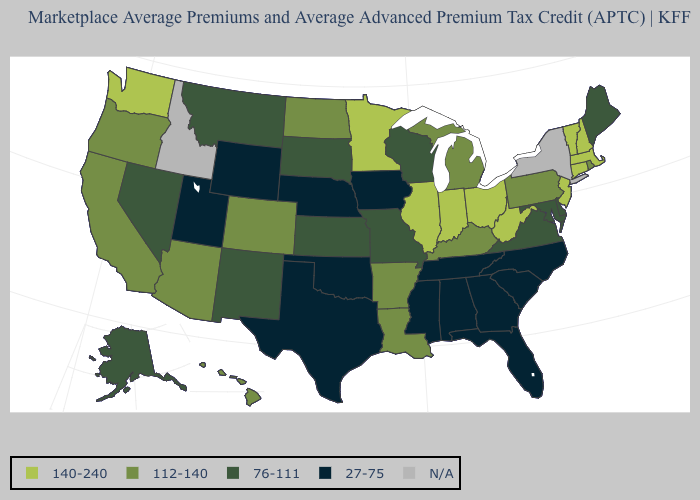What is the value of Maine?
Quick response, please. 76-111. Which states hav the highest value in the West?
Be succinct. Washington. What is the value of Maine?
Keep it brief. 76-111. Which states have the highest value in the USA?
Answer briefly. Connecticut, Illinois, Indiana, Massachusetts, Minnesota, New Hampshire, New Jersey, Ohio, Vermont, Washington, West Virginia. What is the value of Pennsylvania?
Give a very brief answer. 112-140. Is the legend a continuous bar?
Quick response, please. No. What is the lowest value in the USA?
Write a very short answer. 27-75. What is the value of Alabama?
Give a very brief answer. 27-75. Is the legend a continuous bar?
Short answer required. No. What is the value of Arkansas?
Answer briefly. 112-140. Name the states that have a value in the range 140-240?
Concise answer only. Connecticut, Illinois, Indiana, Massachusetts, Minnesota, New Hampshire, New Jersey, Ohio, Vermont, Washington, West Virginia. What is the lowest value in states that border Delaware?
Write a very short answer. 76-111. What is the value of Nebraska?
Keep it brief. 27-75. Is the legend a continuous bar?
Concise answer only. No. Does Utah have the lowest value in the USA?
Write a very short answer. Yes. 